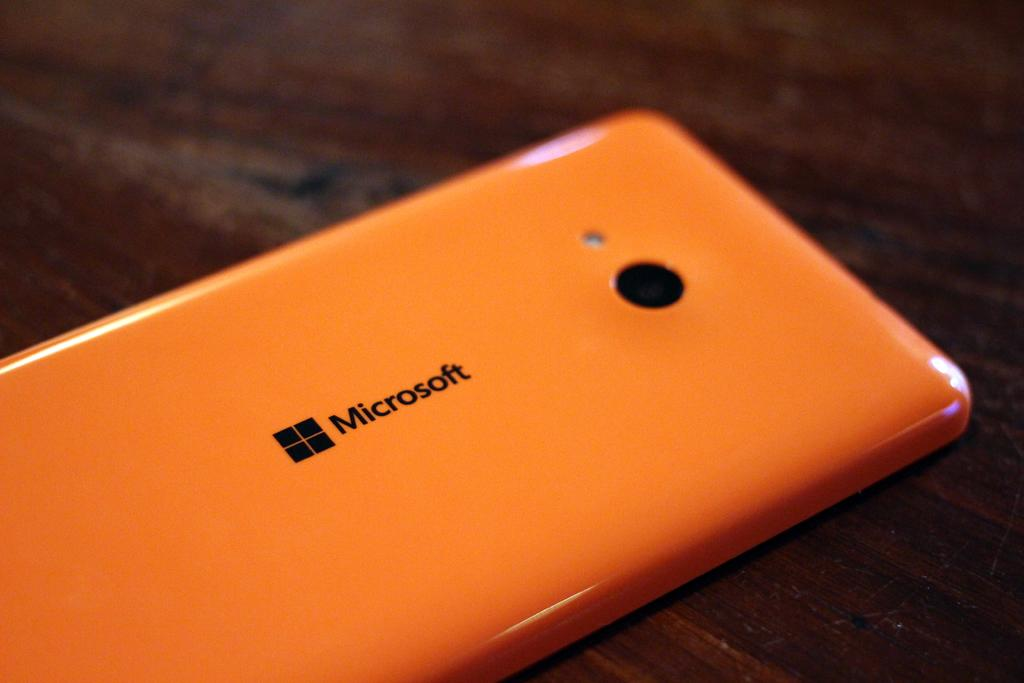<image>
Give a short and clear explanation of the subsequent image. An orange phone from the brand microsoft is on a wooden surface. 